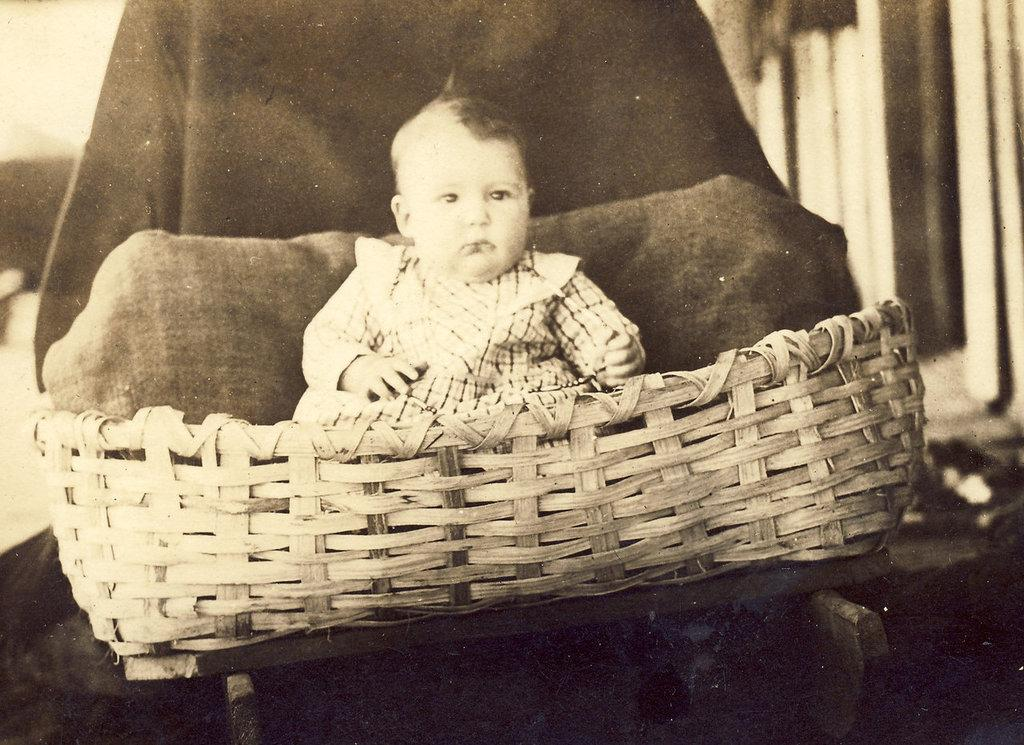What is the color scheme of the image? The image is black and white. What can be seen in the image? There is a baby in the image. Where is the baby sitting? The baby is sitting in a basket. What is visible behind the basket? There are objects behind the basket. How is the background of the image? The background is blurred. What type of discussion is taking place in the image? There is no discussion taking place in the image; it features a baby sitting in a basket with a blurred background. 